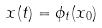Convert formula to latex. <formula><loc_0><loc_0><loc_500><loc_500>x ( t ) = \phi _ { t } ( x _ { 0 } )</formula> 